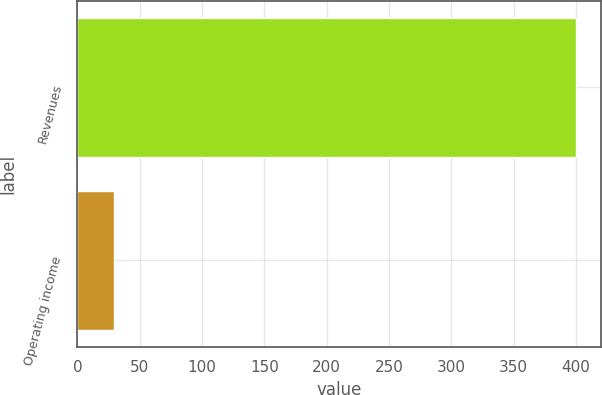Convert chart. <chart><loc_0><loc_0><loc_500><loc_500><bar_chart><fcel>Revenues<fcel>Operating income<nl><fcel>400<fcel>29<nl></chart> 